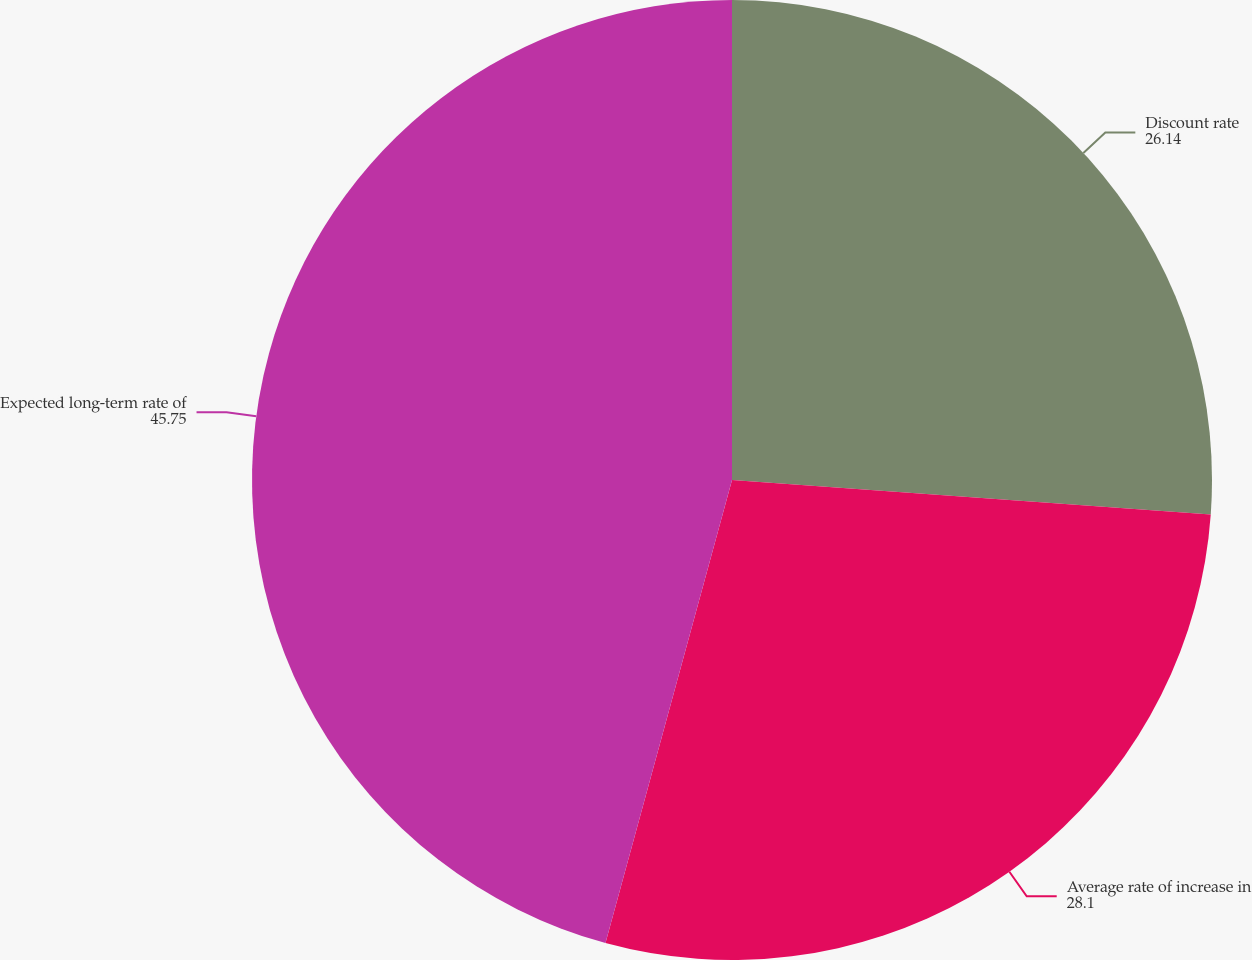<chart> <loc_0><loc_0><loc_500><loc_500><pie_chart><fcel>Discount rate<fcel>Average rate of increase in<fcel>Expected long-term rate of<nl><fcel>26.14%<fcel>28.1%<fcel>45.75%<nl></chart> 